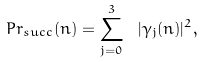Convert formula to latex. <formula><loc_0><loc_0><loc_500><loc_500>P r _ { s u c c } ( n ) = \sum _ { j = 0 } ^ { 3 } \ | \gamma _ { j } ( n ) | ^ { 2 } ,</formula> 